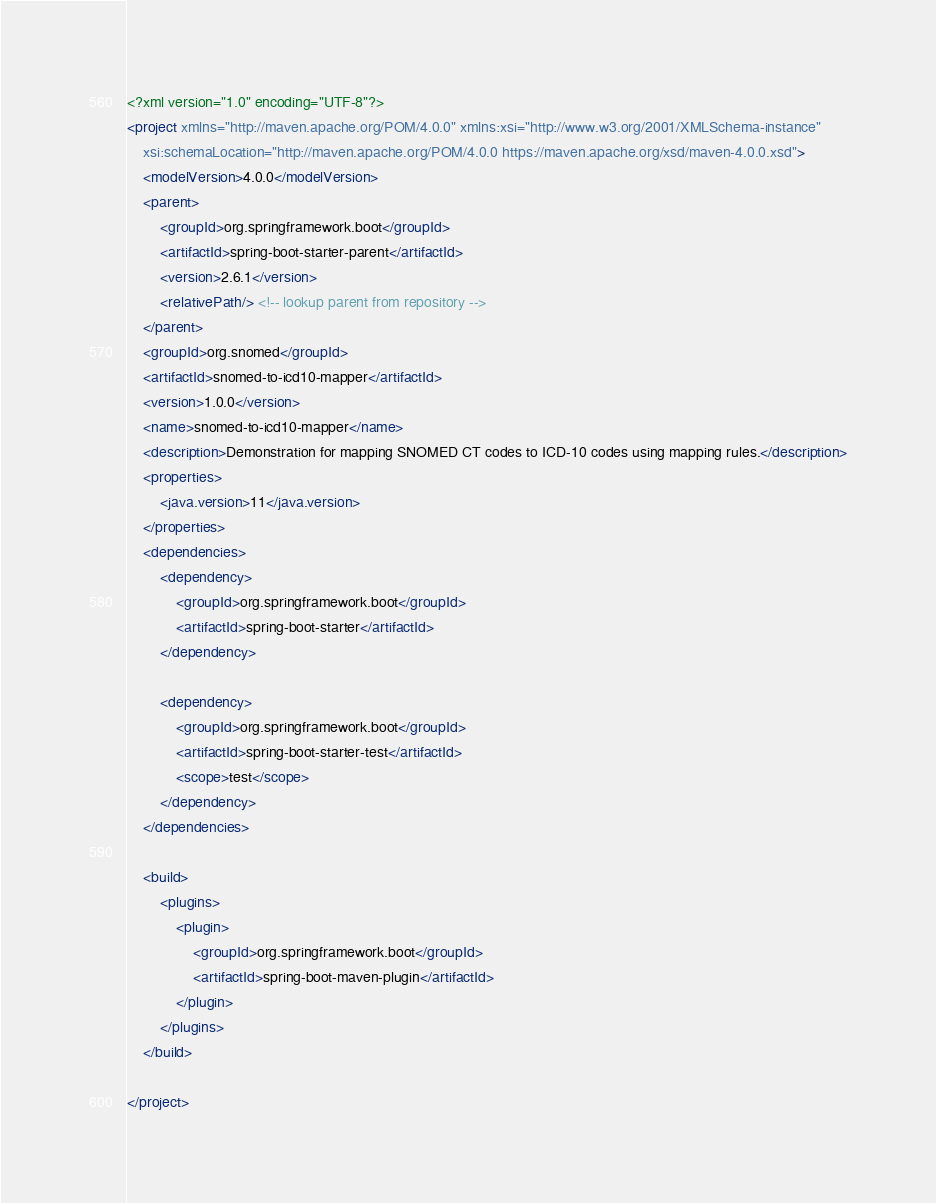<code> <loc_0><loc_0><loc_500><loc_500><_XML_><?xml version="1.0" encoding="UTF-8"?>
<project xmlns="http://maven.apache.org/POM/4.0.0" xmlns:xsi="http://www.w3.org/2001/XMLSchema-instance"
	xsi:schemaLocation="http://maven.apache.org/POM/4.0.0 https://maven.apache.org/xsd/maven-4.0.0.xsd">
	<modelVersion>4.0.0</modelVersion>
	<parent>
		<groupId>org.springframework.boot</groupId>
		<artifactId>spring-boot-starter-parent</artifactId>
		<version>2.6.1</version>
		<relativePath/> <!-- lookup parent from repository -->
	</parent>
	<groupId>org.snomed</groupId>
	<artifactId>snomed-to-icd10-mapper</artifactId>
	<version>1.0.0</version>
	<name>snomed-to-icd10-mapper</name>
	<description>Demonstration for mapping SNOMED CT codes to ICD-10 codes using mapping rules.</description>
	<properties>
		<java.version>11</java.version>
	</properties>
	<dependencies>
		<dependency>
			<groupId>org.springframework.boot</groupId>
			<artifactId>spring-boot-starter</artifactId>
		</dependency>

		<dependency>
			<groupId>org.springframework.boot</groupId>
			<artifactId>spring-boot-starter-test</artifactId>
			<scope>test</scope>
		</dependency>
	</dependencies>

	<build>
		<plugins>
			<plugin>
				<groupId>org.springframework.boot</groupId>
				<artifactId>spring-boot-maven-plugin</artifactId>
			</plugin>
		</plugins>
	</build>

</project>
</code> 